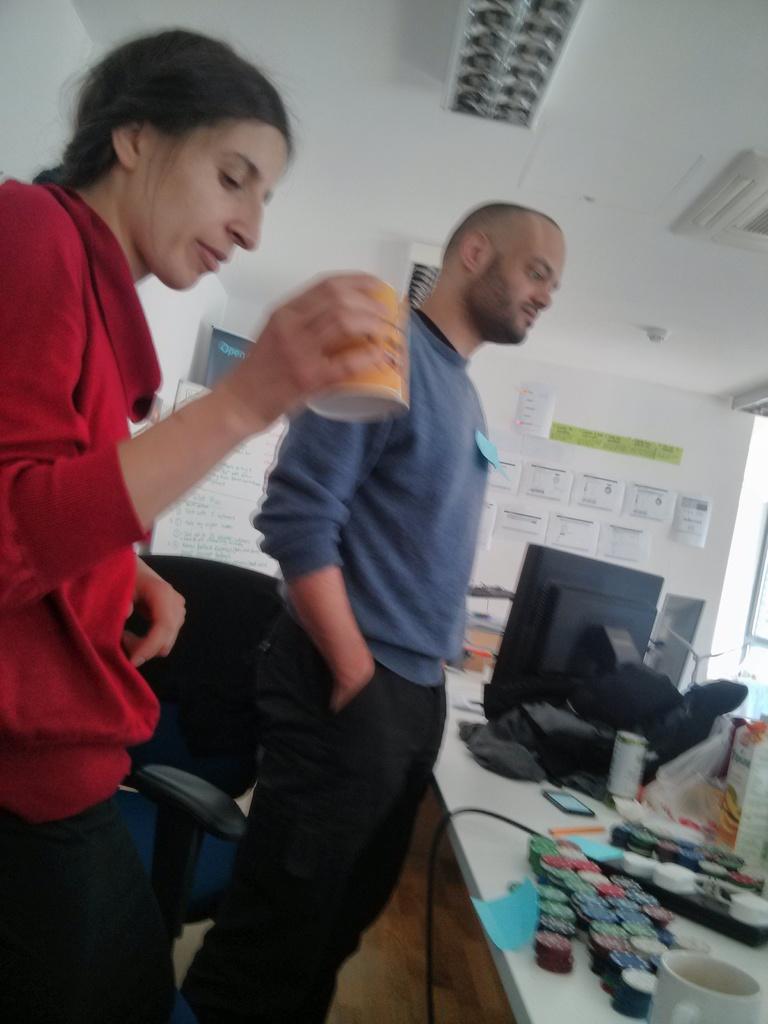Could you give a brief overview of what you see in this image? In the image we can see there are people standing and a woman is holding mug in her hand. There are coins, coffee mug, ipod, monitor and box kept on the table. There are paper clips attached on the wall and there are lights on the top. There is a chair kept on the floor. 